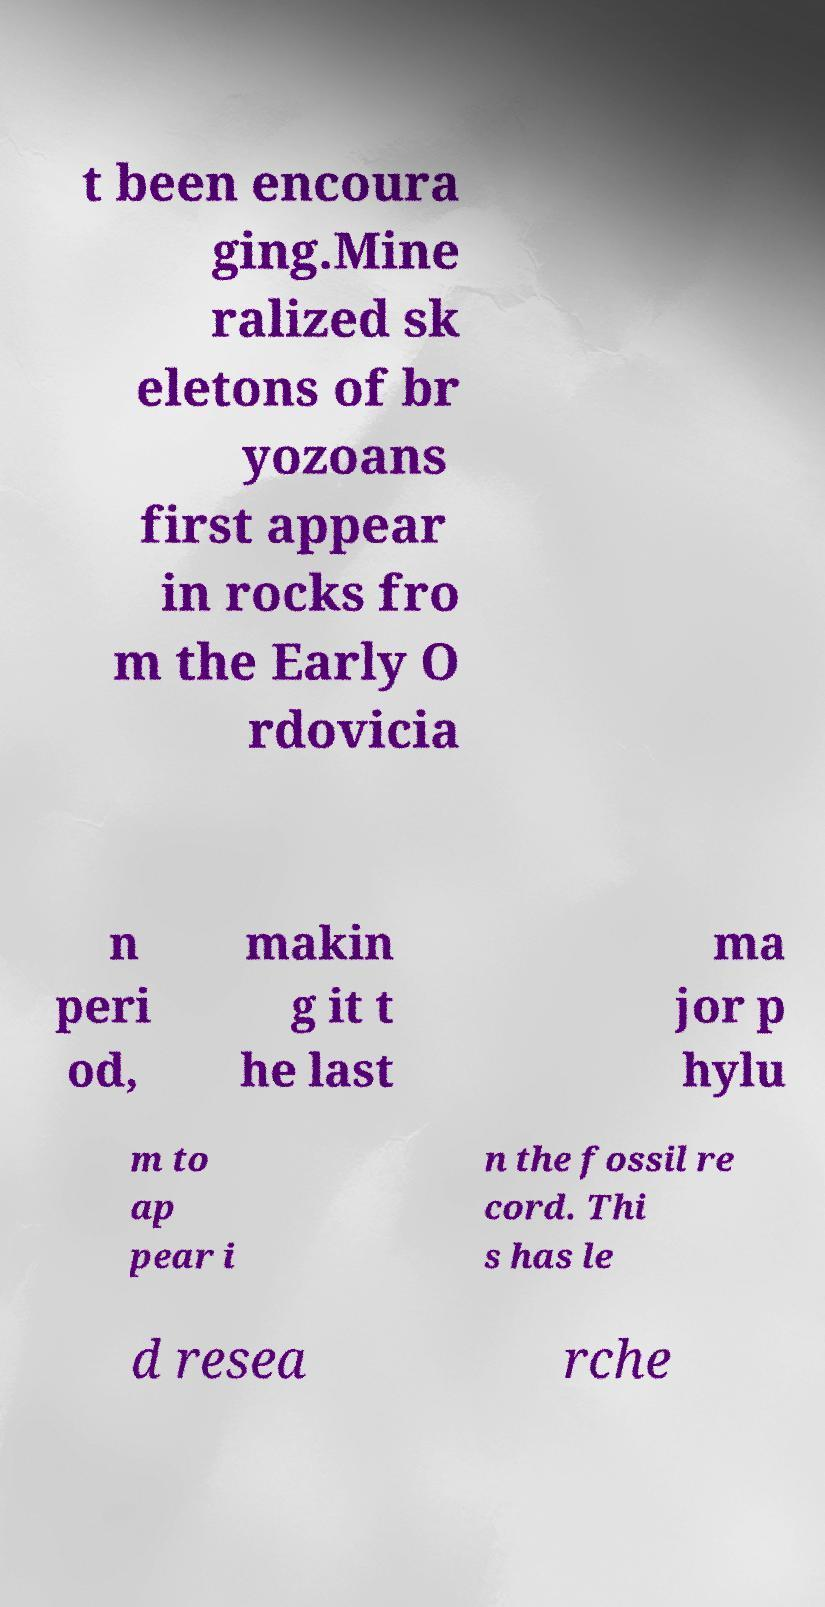Can you read and provide the text displayed in the image?This photo seems to have some interesting text. Can you extract and type it out for me? t been encoura ging.Mine ralized sk eletons of br yozoans first appear in rocks fro m the Early O rdovicia n peri od, makin g it t he last ma jor p hylu m to ap pear i n the fossil re cord. Thi s has le d resea rche 